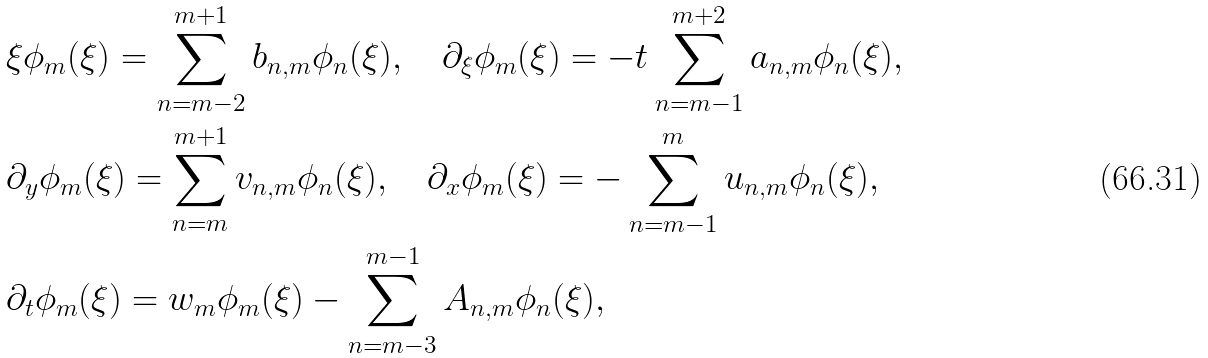Convert formula to latex. <formula><loc_0><loc_0><loc_500><loc_500>& \xi \phi _ { m } ( \xi ) = \sum _ { n = m - 2 } ^ { m + 1 } b _ { n , m } \phi _ { n } ( \xi ) , \quad \partial _ { \xi } \phi _ { m } ( \xi ) = - t \sum _ { n = m - 1 } ^ { m + 2 } a _ { n , m } \phi _ { n } ( \xi ) , \\ & \partial _ { y } \phi _ { m } ( \xi ) = \sum _ { n = m } ^ { m + 1 } v _ { n , m } \phi _ { n } ( \xi ) , \quad \partial _ { x } \phi _ { m } ( \xi ) = - \sum _ { n = m - 1 } ^ { m } u _ { n , m } \phi _ { n } ( \xi ) , \\ & \partial _ { t } \phi _ { m } ( \xi ) = w _ { m } \phi _ { m } ( \xi ) - \sum _ { n = m - 3 } ^ { m - 1 } A _ { n , m } \phi _ { n } ( \xi ) ,</formula> 